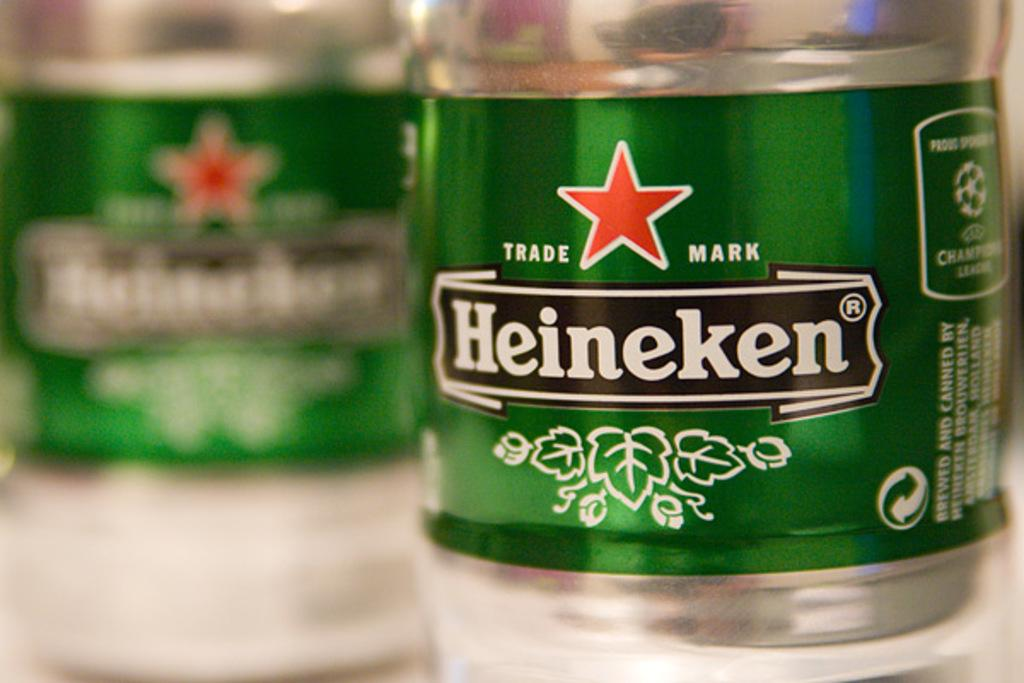What type of bottle is visible in the image? There is a bottle with a Heineken label in the image. Can you describe the other bottle in the image? There is another bottle on the left side of the image, which is slightly blurred. What does the hall taste like in the image? There is no mention of a hall in the image, so it is not possible to determine its taste. 